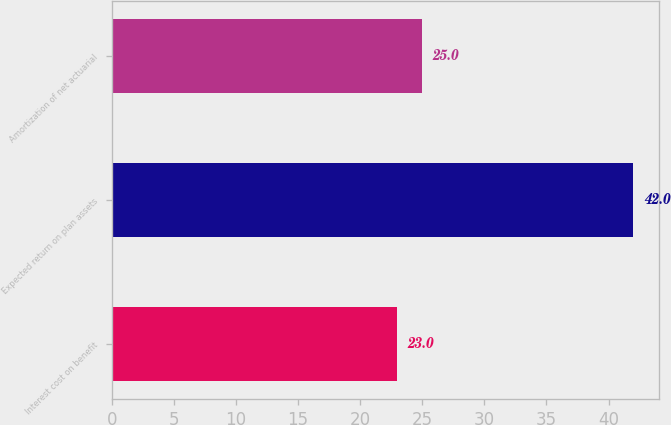<chart> <loc_0><loc_0><loc_500><loc_500><bar_chart><fcel>Interest cost on benefit<fcel>Expected return on plan assets<fcel>Amortization of net actuarial<nl><fcel>23<fcel>42<fcel>25<nl></chart> 